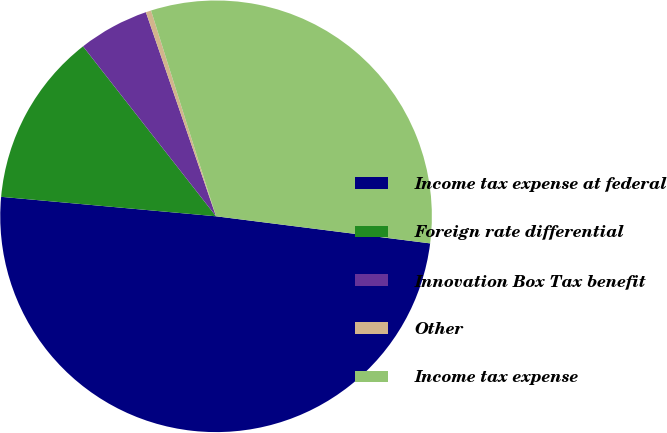<chart> <loc_0><loc_0><loc_500><loc_500><pie_chart><fcel>Income tax expense at federal<fcel>Foreign rate differential<fcel>Innovation Box Tax benefit<fcel>Other<fcel>Income tax expense<nl><fcel>49.43%<fcel>12.99%<fcel>5.3%<fcel>0.4%<fcel>31.87%<nl></chart> 